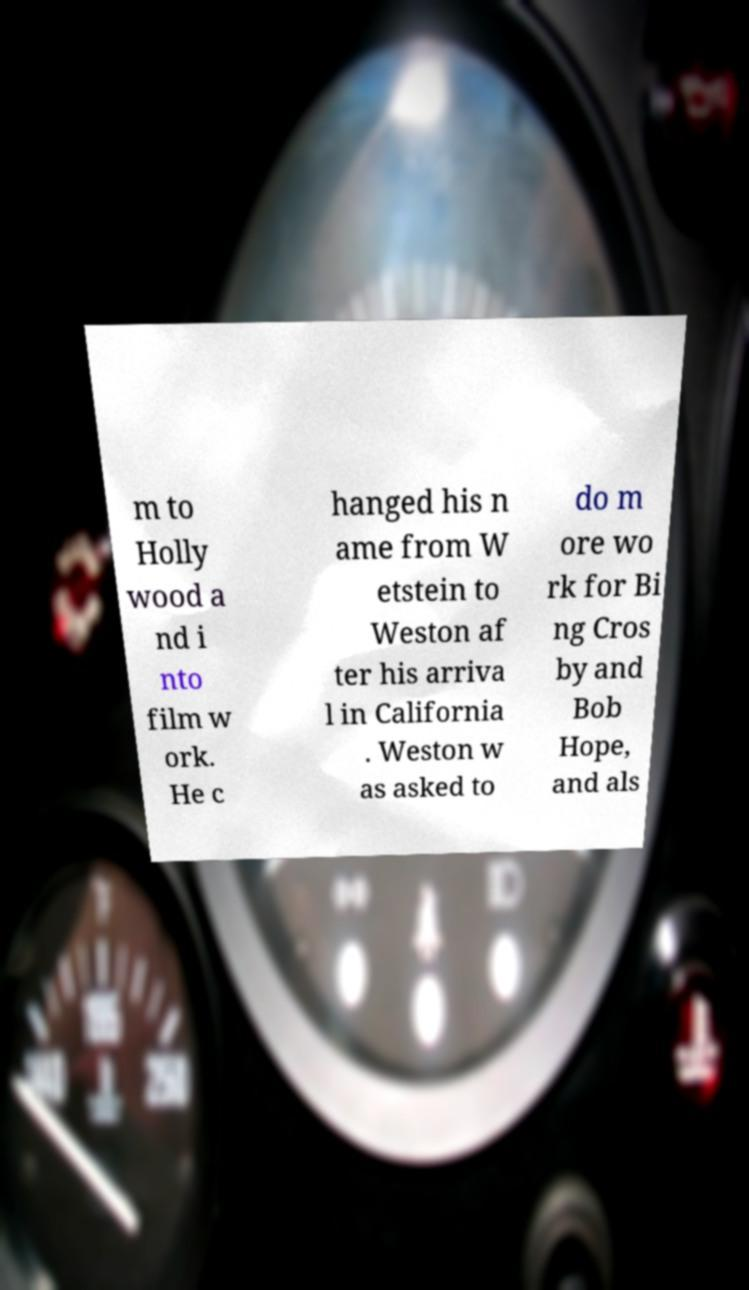I need the written content from this picture converted into text. Can you do that? m to Holly wood a nd i nto film w ork. He c hanged his n ame from W etstein to Weston af ter his arriva l in California . Weston w as asked to do m ore wo rk for Bi ng Cros by and Bob Hope, and als 